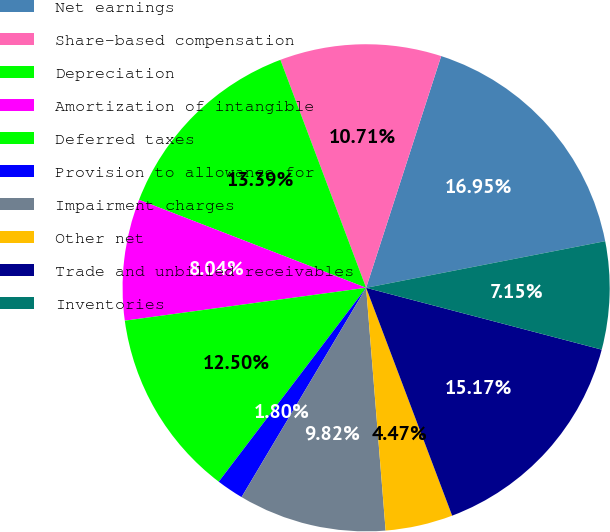Convert chart. <chart><loc_0><loc_0><loc_500><loc_500><pie_chart><fcel>Net earnings<fcel>Share-based compensation<fcel>Depreciation<fcel>Amortization of intangible<fcel>Deferred taxes<fcel>Provision to allowance for<fcel>Impairment charges<fcel>Other net<fcel>Trade and unbilled receivables<fcel>Inventories<nl><fcel>16.95%<fcel>10.71%<fcel>13.39%<fcel>8.04%<fcel>12.5%<fcel>1.8%<fcel>9.82%<fcel>4.47%<fcel>15.17%<fcel>7.15%<nl></chart> 